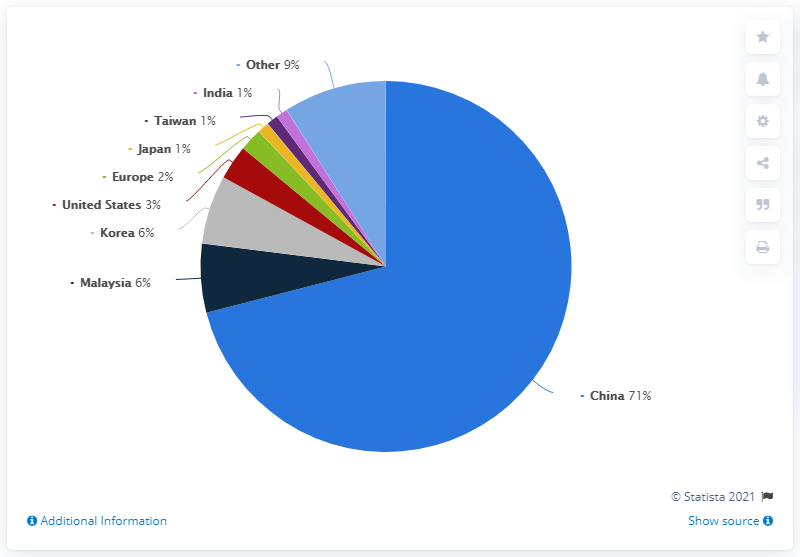what is the distribution of sum of India and China? Based on the pie chart, the distribution of China alone is 71%. Since India's distribution is mentioned as 1%, the combined total distribution of both India and China is 72%. It is important to note that the percentages represent a specific dataset, which is not specified in the chart. For a comprehensive understanding, the context of the data such as the year, geographical scope, and dataset criteria are crucial. 